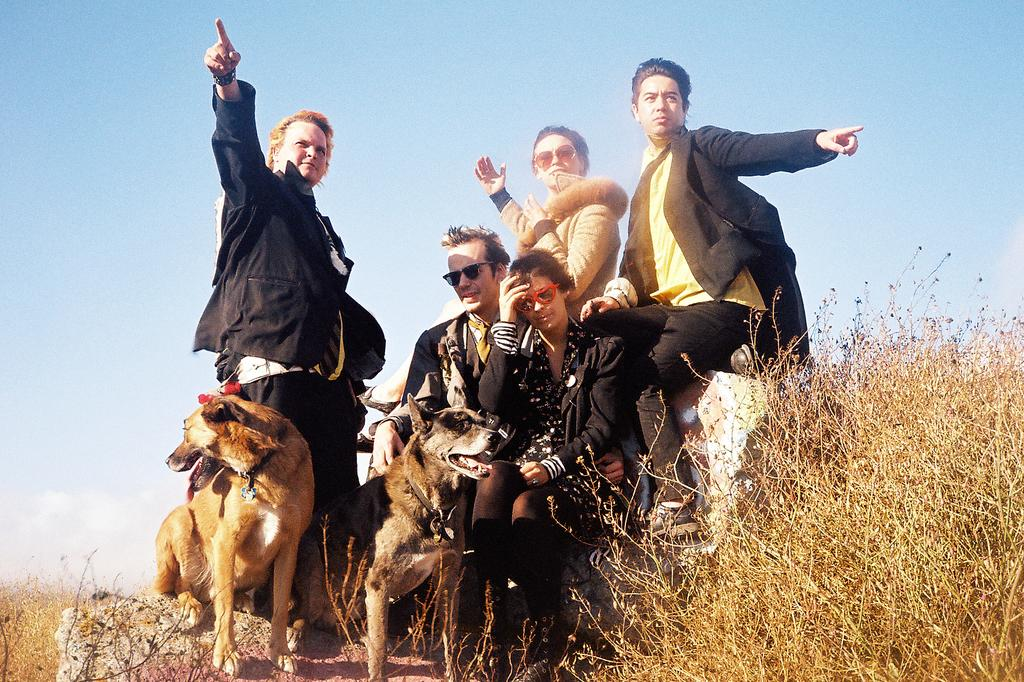How many people are in the image? There are three men and two women in the image, making a total of five people. What other living beings are present in the image? There are two dogs in the image. What type of vegetation can be seen on the right side of the image? There is grass on the right side of the image. What is visible in the background of the image? There is sky visible in the background of the image. How many goldfish can be seen swimming in the image? There are no goldfish present in the image. What type of comfort is provided by the cars in the image? There are no cars present in the image, so comfort provided by cars cannot be determined. 